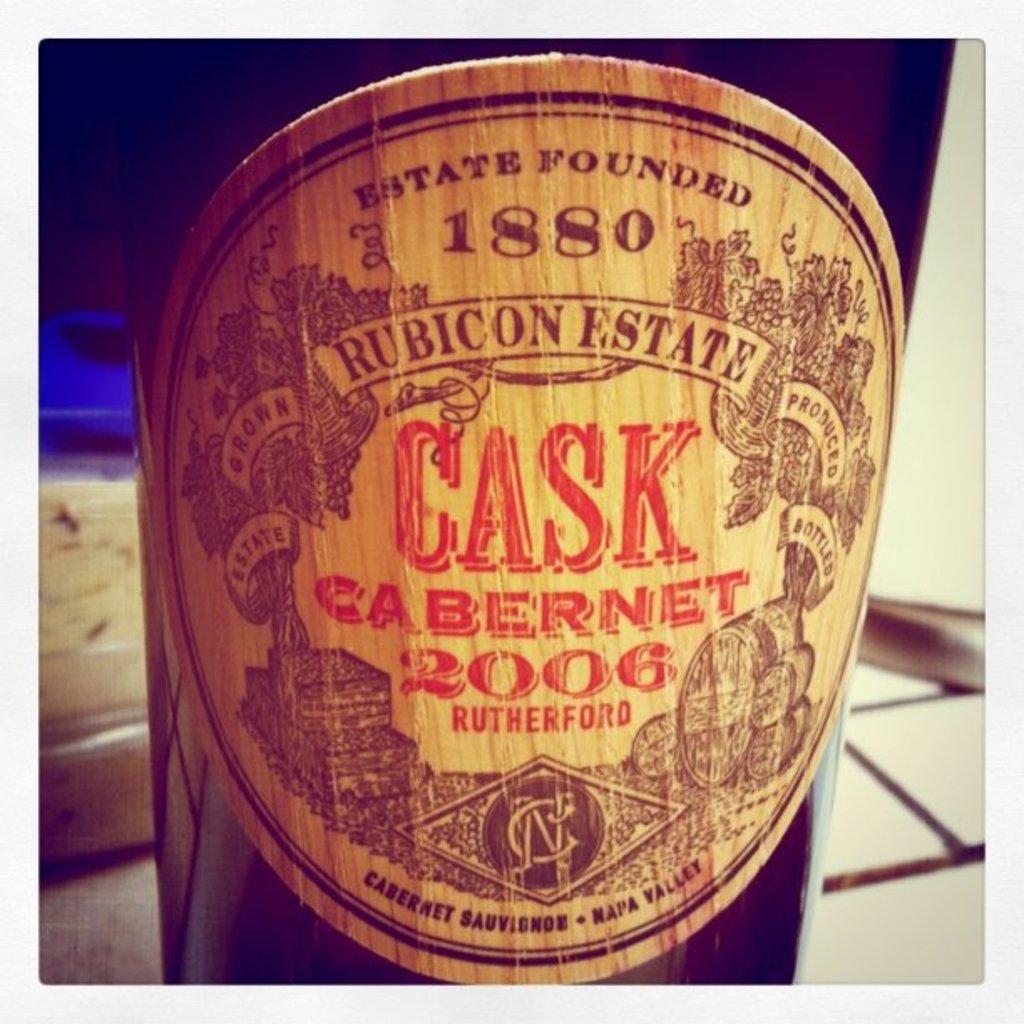What year is this wine?
Your response must be concise. 2006. What valley is this wine from?
Give a very brief answer. Napa. 